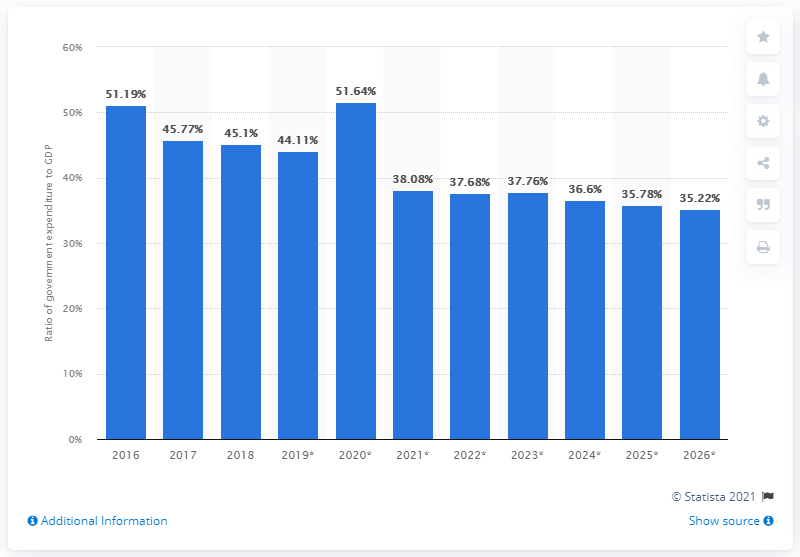Outline some significant characteristics in this image. In 2018, government expenditure in Oman accounted for 45.1% of the country's gross domestic product. 